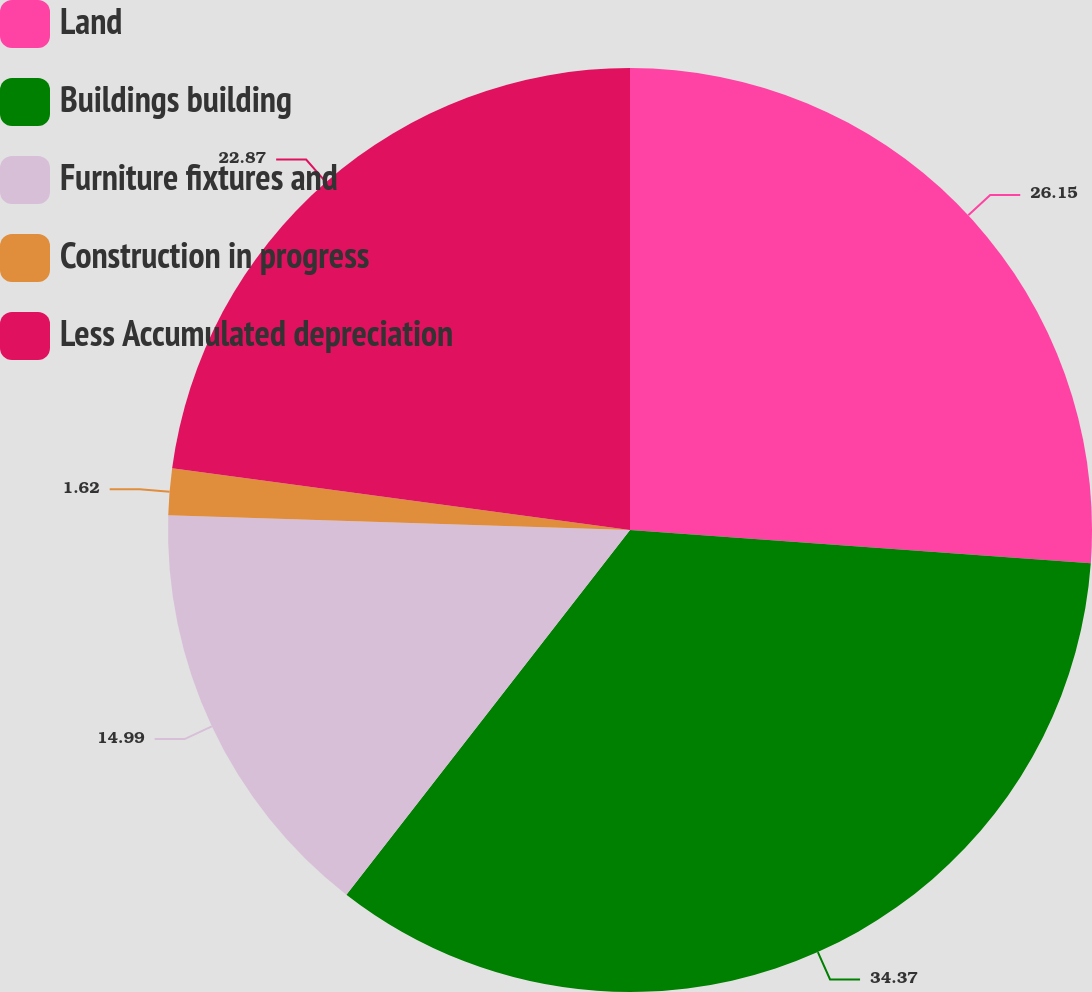<chart> <loc_0><loc_0><loc_500><loc_500><pie_chart><fcel>Land<fcel>Buildings building<fcel>Furniture fixtures and<fcel>Construction in progress<fcel>Less Accumulated depreciation<nl><fcel>26.15%<fcel>34.37%<fcel>14.99%<fcel>1.62%<fcel>22.87%<nl></chart> 